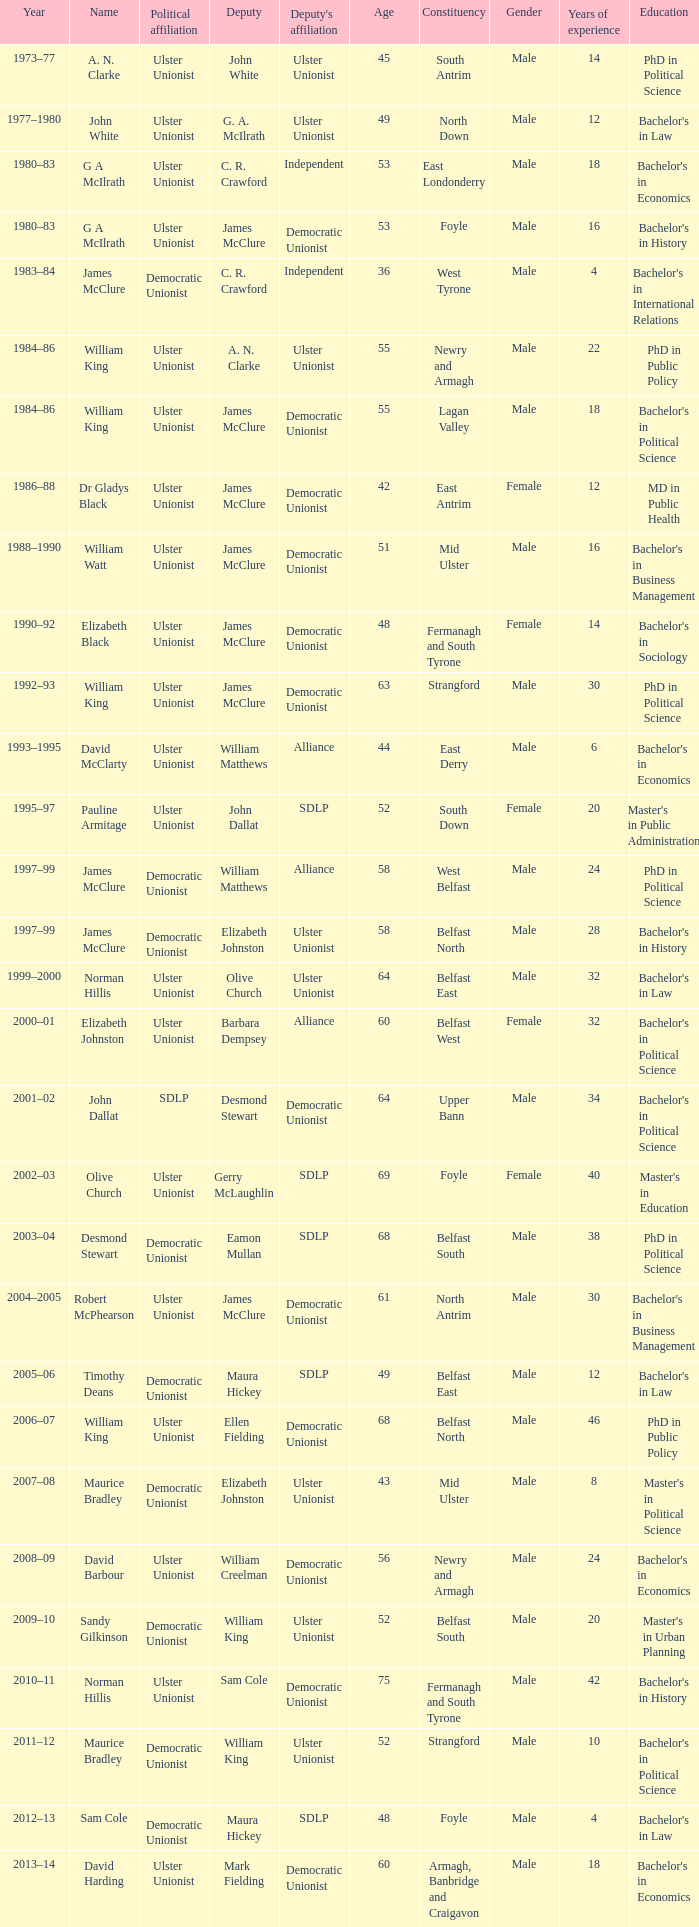What is the Political affiliation of deputy john dallat? Ulster Unionist. 